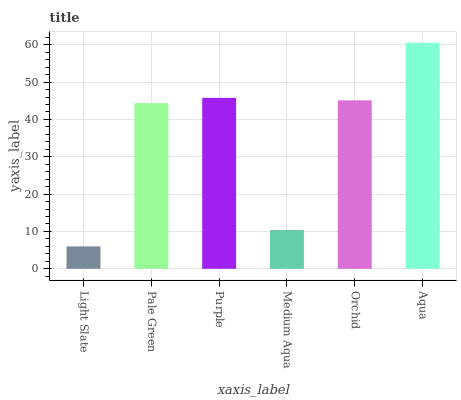Is Light Slate the minimum?
Answer yes or no. Yes. Is Aqua the maximum?
Answer yes or no. Yes. Is Pale Green the minimum?
Answer yes or no. No. Is Pale Green the maximum?
Answer yes or no. No. Is Pale Green greater than Light Slate?
Answer yes or no. Yes. Is Light Slate less than Pale Green?
Answer yes or no. Yes. Is Light Slate greater than Pale Green?
Answer yes or no. No. Is Pale Green less than Light Slate?
Answer yes or no. No. Is Orchid the high median?
Answer yes or no. Yes. Is Pale Green the low median?
Answer yes or no. Yes. Is Light Slate the high median?
Answer yes or no. No. Is Medium Aqua the low median?
Answer yes or no. No. 